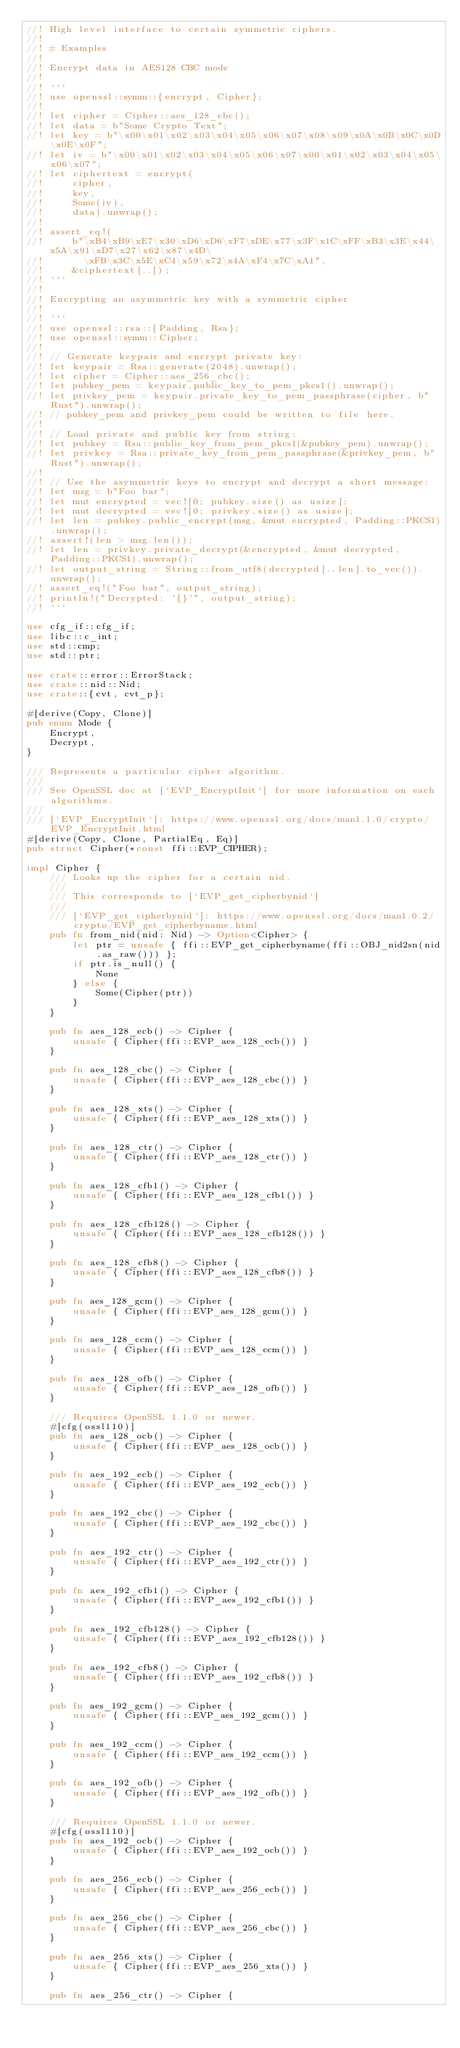<code> <loc_0><loc_0><loc_500><loc_500><_Rust_>//! High level interface to certain symmetric ciphers.
//!
//! # Examples
//!
//! Encrypt data in AES128 CBC mode
//!
//! ```
//! use openssl::symm::{encrypt, Cipher};
//!
//! let cipher = Cipher::aes_128_cbc();
//! let data = b"Some Crypto Text";
//! let key = b"\x00\x01\x02\x03\x04\x05\x06\x07\x08\x09\x0A\x0B\x0C\x0D\x0E\x0F";
//! let iv = b"\x00\x01\x02\x03\x04\x05\x06\x07\x00\x01\x02\x03\x04\x05\x06\x07";
//! let ciphertext = encrypt(
//!     cipher,
//!     key,
//!     Some(iv),
//!     data).unwrap();
//!
//! assert_eq!(
//!     b"\xB4\xB9\xE7\x30\xD6\xD6\xF7\xDE\x77\x3F\x1C\xFF\xB3\x3E\x44\x5A\x91\xD7\x27\x62\x87\x4D\
//!       \xFB\x3C\x5E\xC4\x59\x72\x4A\xF4\x7C\xA1",
//!     &ciphertext[..]);
//! ```
//!
//! Encrypting an asymmetric key with a symmetric cipher
//!
//! ```
//! use openssl::rsa::{Padding, Rsa};
//! use openssl::symm::Cipher;
//!
//! // Generate keypair and encrypt private key:
//! let keypair = Rsa::generate(2048).unwrap();
//! let cipher = Cipher::aes_256_cbc();
//! let pubkey_pem = keypair.public_key_to_pem_pkcs1().unwrap();
//! let privkey_pem = keypair.private_key_to_pem_passphrase(cipher, b"Rust").unwrap();
//! // pubkey_pem and privkey_pem could be written to file here.
//!
//! // Load private and public key from string:
//! let pubkey = Rsa::public_key_from_pem_pkcs1(&pubkey_pem).unwrap();
//! let privkey = Rsa::private_key_from_pem_passphrase(&privkey_pem, b"Rust").unwrap();
//!
//! // Use the asymmetric keys to encrypt and decrypt a short message:
//! let msg = b"Foo bar";
//! let mut encrypted = vec![0; pubkey.size() as usize];
//! let mut decrypted = vec![0; privkey.size() as usize];
//! let len = pubkey.public_encrypt(msg, &mut encrypted, Padding::PKCS1).unwrap();
//! assert!(len > msg.len());
//! let len = privkey.private_decrypt(&encrypted, &mut decrypted, Padding::PKCS1).unwrap();
//! let output_string = String::from_utf8(decrypted[..len].to_vec()).unwrap();
//! assert_eq!("Foo bar", output_string);
//! println!("Decrypted: '{}'", output_string);
//! ```

use cfg_if::cfg_if;
use libc::c_int;
use std::cmp;
use std::ptr;

use crate::error::ErrorStack;
use crate::nid::Nid;
use crate::{cvt, cvt_p};

#[derive(Copy, Clone)]
pub enum Mode {
    Encrypt,
    Decrypt,
}

/// Represents a particular cipher algorithm.
///
/// See OpenSSL doc at [`EVP_EncryptInit`] for more information on each algorithms.
///
/// [`EVP_EncryptInit`]: https://www.openssl.org/docs/man1.1.0/crypto/EVP_EncryptInit.html
#[derive(Copy, Clone, PartialEq, Eq)]
pub struct Cipher(*const ffi::EVP_CIPHER);

impl Cipher {
    /// Looks up the cipher for a certain nid.
    ///
    /// This corresponds to [`EVP_get_cipherbynid`]
    ///
    /// [`EVP_get_cipherbynid`]: https://www.openssl.org/docs/man1.0.2/crypto/EVP_get_cipherbyname.html
    pub fn from_nid(nid: Nid) -> Option<Cipher> {
        let ptr = unsafe { ffi::EVP_get_cipherbyname(ffi::OBJ_nid2sn(nid.as_raw())) };
        if ptr.is_null() {
            None
        } else {
            Some(Cipher(ptr))
        }
    }

    pub fn aes_128_ecb() -> Cipher {
        unsafe { Cipher(ffi::EVP_aes_128_ecb()) }
    }

    pub fn aes_128_cbc() -> Cipher {
        unsafe { Cipher(ffi::EVP_aes_128_cbc()) }
    }

    pub fn aes_128_xts() -> Cipher {
        unsafe { Cipher(ffi::EVP_aes_128_xts()) }
    }

    pub fn aes_128_ctr() -> Cipher {
        unsafe { Cipher(ffi::EVP_aes_128_ctr()) }
    }

    pub fn aes_128_cfb1() -> Cipher {
        unsafe { Cipher(ffi::EVP_aes_128_cfb1()) }
    }

    pub fn aes_128_cfb128() -> Cipher {
        unsafe { Cipher(ffi::EVP_aes_128_cfb128()) }
    }

    pub fn aes_128_cfb8() -> Cipher {
        unsafe { Cipher(ffi::EVP_aes_128_cfb8()) }
    }

    pub fn aes_128_gcm() -> Cipher {
        unsafe { Cipher(ffi::EVP_aes_128_gcm()) }
    }

    pub fn aes_128_ccm() -> Cipher {
        unsafe { Cipher(ffi::EVP_aes_128_ccm()) }
    }

    pub fn aes_128_ofb() -> Cipher {
        unsafe { Cipher(ffi::EVP_aes_128_ofb()) }
    }

    /// Requires OpenSSL 1.1.0 or newer.
    #[cfg(ossl110)]
    pub fn aes_128_ocb() -> Cipher {
        unsafe { Cipher(ffi::EVP_aes_128_ocb()) }
    }

    pub fn aes_192_ecb() -> Cipher {
        unsafe { Cipher(ffi::EVP_aes_192_ecb()) }
    }

    pub fn aes_192_cbc() -> Cipher {
        unsafe { Cipher(ffi::EVP_aes_192_cbc()) }
    }

    pub fn aes_192_ctr() -> Cipher {
        unsafe { Cipher(ffi::EVP_aes_192_ctr()) }
    }

    pub fn aes_192_cfb1() -> Cipher {
        unsafe { Cipher(ffi::EVP_aes_192_cfb1()) }
    }

    pub fn aes_192_cfb128() -> Cipher {
        unsafe { Cipher(ffi::EVP_aes_192_cfb128()) }
    }

    pub fn aes_192_cfb8() -> Cipher {
        unsafe { Cipher(ffi::EVP_aes_192_cfb8()) }
    }

    pub fn aes_192_gcm() -> Cipher {
        unsafe { Cipher(ffi::EVP_aes_192_gcm()) }
    }

    pub fn aes_192_ccm() -> Cipher {
        unsafe { Cipher(ffi::EVP_aes_192_ccm()) }
    }

    pub fn aes_192_ofb() -> Cipher {
        unsafe { Cipher(ffi::EVP_aes_192_ofb()) }
    }

    /// Requires OpenSSL 1.1.0 or newer.
    #[cfg(ossl110)]
    pub fn aes_192_ocb() -> Cipher {
        unsafe { Cipher(ffi::EVP_aes_192_ocb()) }
    }

    pub fn aes_256_ecb() -> Cipher {
        unsafe { Cipher(ffi::EVP_aes_256_ecb()) }
    }

    pub fn aes_256_cbc() -> Cipher {
        unsafe { Cipher(ffi::EVP_aes_256_cbc()) }
    }

    pub fn aes_256_xts() -> Cipher {
        unsafe { Cipher(ffi::EVP_aes_256_xts()) }
    }

    pub fn aes_256_ctr() -> Cipher {</code> 